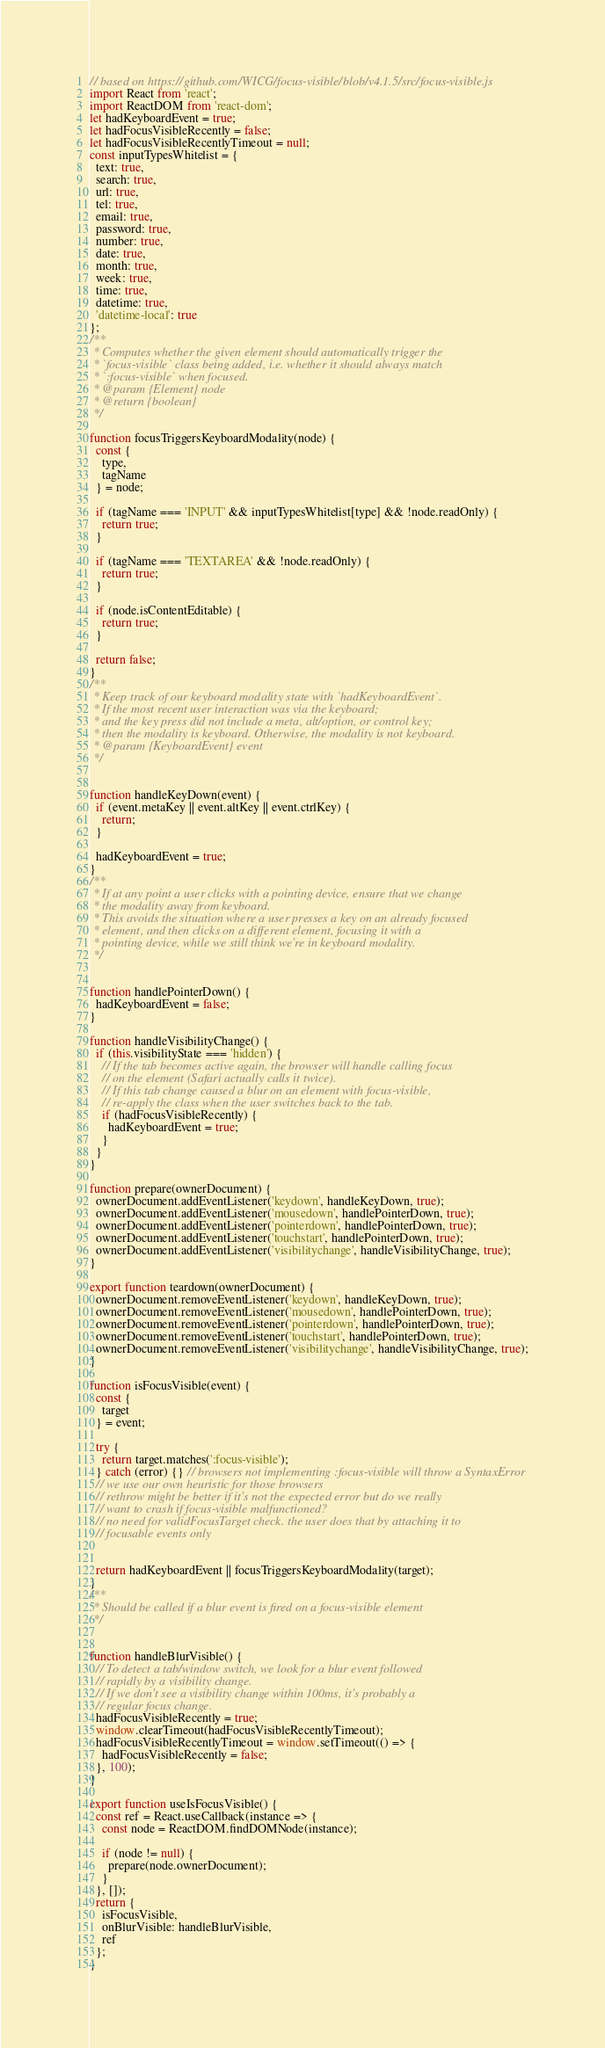Convert code to text. <code><loc_0><loc_0><loc_500><loc_500><_JavaScript_>// based on https://github.com/WICG/focus-visible/blob/v4.1.5/src/focus-visible.js
import React from 'react';
import ReactDOM from 'react-dom';
let hadKeyboardEvent = true;
let hadFocusVisibleRecently = false;
let hadFocusVisibleRecentlyTimeout = null;
const inputTypesWhitelist = {
  text: true,
  search: true,
  url: true,
  tel: true,
  email: true,
  password: true,
  number: true,
  date: true,
  month: true,
  week: true,
  time: true,
  datetime: true,
  'datetime-local': true
};
/**
 * Computes whether the given element should automatically trigger the
 * `focus-visible` class being added, i.e. whether it should always match
 * `:focus-visible` when focused.
 * @param {Element} node
 * @return {boolean}
 */

function focusTriggersKeyboardModality(node) {
  const {
    type,
    tagName
  } = node;

  if (tagName === 'INPUT' && inputTypesWhitelist[type] && !node.readOnly) {
    return true;
  }

  if (tagName === 'TEXTAREA' && !node.readOnly) {
    return true;
  }

  if (node.isContentEditable) {
    return true;
  }

  return false;
}
/**
 * Keep track of our keyboard modality state with `hadKeyboardEvent`.
 * If the most recent user interaction was via the keyboard;
 * and the key press did not include a meta, alt/option, or control key;
 * then the modality is keyboard. Otherwise, the modality is not keyboard.
 * @param {KeyboardEvent} event
 */


function handleKeyDown(event) {
  if (event.metaKey || event.altKey || event.ctrlKey) {
    return;
  }

  hadKeyboardEvent = true;
}
/**
 * If at any point a user clicks with a pointing device, ensure that we change
 * the modality away from keyboard.
 * This avoids the situation where a user presses a key on an already focused
 * element, and then clicks on a different element, focusing it with a
 * pointing device, while we still think we're in keyboard modality.
 */


function handlePointerDown() {
  hadKeyboardEvent = false;
}

function handleVisibilityChange() {
  if (this.visibilityState === 'hidden') {
    // If the tab becomes active again, the browser will handle calling focus
    // on the element (Safari actually calls it twice).
    // If this tab change caused a blur on an element with focus-visible,
    // re-apply the class when the user switches back to the tab.
    if (hadFocusVisibleRecently) {
      hadKeyboardEvent = true;
    }
  }
}

function prepare(ownerDocument) {
  ownerDocument.addEventListener('keydown', handleKeyDown, true);
  ownerDocument.addEventListener('mousedown', handlePointerDown, true);
  ownerDocument.addEventListener('pointerdown', handlePointerDown, true);
  ownerDocument.addEventListener('touchstart', handlePointerDown, true);
  ownerDocument.addEventListener('visibilitychange', handleVisibilityChange, true);
}

export function teardown(ownerDocument) {
  ownerDocument.removeEventListener('keydown', handleKeyDown, true);
  ownerDocument.removeEventListener('mousedown', handlePointerDown, true);
  ownerDocument.removeEventListener('pointerdown', handlePointerDown, true);
  ownerDocument.removeEventListener('touchstart', handlePointerDown, true);
  ownerDocument.removeEventListener('visibilitychange', handleVisibilityChange, true);
}

function isFocusVisible(event) {
  const {
    target
  } = event;

  try {
    return target.matches(':focus-visible');
  } catch (error) {} // browsers not implementing :focus-visible will throw a SyntaxError
  // we use our own heuristic for those browsers
  // rethrow might be better if it's not the expected error but do we really
  // want to crash if focus-visible malfunctioned?
  // no need for validFocusTarget check. the user does that by attaching it to
  // focusable events only


  return hadKeyboardEvent || focusTriggersKeyboardModality(target);
}
/**
 * Should be called if a blur event is fired on a focus-visible element
 */


function handleBlurVisible() {
  // To detect a tab/window switch, we look for a blur event followed
  // rapidly by a visibility change.
  // If we don't see a visibility change within 100ms, it's probably a
  // regular focus change.
  hadFocusVisibleRecently = true;
  window.clearTimeout(hadFocusVisibleRecentlyTimeout);
  hadFocusVisibleRecentlyTimeout = window.setTimeout(() => {
    hadFocusVisibleRecently = false;
  }, 100);
}

export function useIsFocusVisible() {
  const ref = React.useCallback(instance => {
    const node = ReactDOM.findDOMNode(instance);

    if (node != null) {
      prepare(node.ownerDocument);
    }
  }, []);
  return {
    isFocusVisible,
    onBlurVisible: handleBlurVisible,
    ref
  };
}</code> 